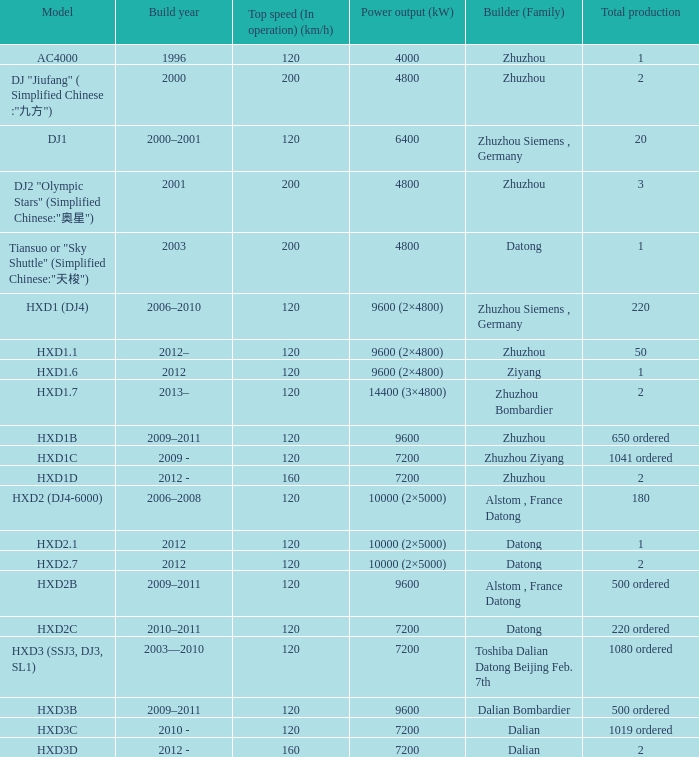Can you parse all the data within this table? {'header': ['Model', 'Build year', 'Top speed (In operation) (km/h)', 'Power output (kW)', 'Builder (Family)', 'Total production'], 'rows': [['AC4000', '1996', '120', '4000', 'Zhuzhou', '1'], ['DJ "Jiufang" ( Simplified Chinese :"九方")', '2000', '200', '4800', 'Zhuzhou', '2'], ['DJ1', '2000–2001', '120', '6400', 'Zhuzhou Siemens , Germany', '20'], ['DJ2 "Olympic Stars" (Simplified Chinese:"奥星")', '2001', '200', '4800', 'Zhuzhou', '3'], ['Tiansuo or "Sky Shuttle" (Simplified Chinese:"天梭")', '2003', '200', '4800', 'Datong', '1'], ['HXD1 (DJ4)', '2006–2010', '120', '9600 (2×4800)', 'Zhuzhou Siemens , Germany', '220'], ['HXD1.1', '2012–', '120', '9600 (2×4800)', 'Zhuzhou', '50'], ['HXD1.6', '2012', '120', '9600 (2×4800)', 'Ziyang', '1'], ['HXD1.7', '2013–', '120', '14400 (3×4800)', 'Zhuzhou Bombardier', '2'], ['HXD1B', '2009–2011', '120', '9600', 'Zhuzhou', '650 ordered'], ['HXD1C', '2009 -', '120', '7200', 'Zhuzhou Ziyang', '1041 ordered'], ['HXD1D', '2012 -', '160', '7200', 'Zhuzhou', '2'], ['HXD2 (DJ4-6000)', '2006–2008', '120', '10000 (2×5000)', 'Alstom , France Datong', '180'], ['HXD2.1', '2012', '120', '10000 (2×5000)', 'Datong', '1'], ['HXD2.7', '2012', '120', '10000 (2×5000)', 'Datong', '2'], ['HXD2B', '2009–2011', '120', '9600', 'Alstom , France Datong', '500 ordered'], ['HXD2C', '2010–2011', '120', '7200', 'Datong', '220 ordered'], ['HXD3 (SSJ3, DJ3, SL1)', '2003—2010', '120', '7200', 'Toshiba Dalian Datong Beijing Feb. 7th', '1080 ordered'], ['HXD3B', '2009–2011', '120', '9600', 'Dalian Bombardier', '500 ordered'], ['HXD3C', '2010 -', '120', '7200', 'Dalian', '1019 ordered'], ['HXD3D', '2012 -', '160', '7200', 'Dalian', '2']]} What model has a builder of zhuzhou, and a power output of 9600 (kw)? HXD1B. 